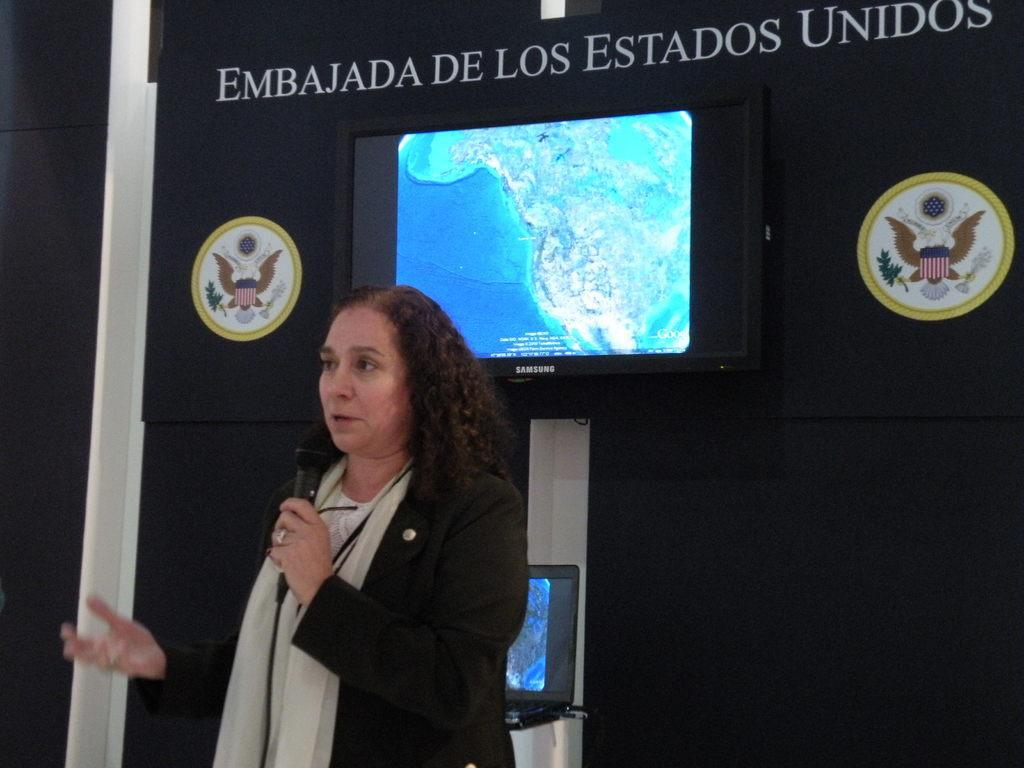Could you give a brief overview of what you see in this image? In the picture I can see a woman wearing black color dress standing and holding microphone in her hands and in the background of the picture there is black color sheet, there is a screen and laptop. 